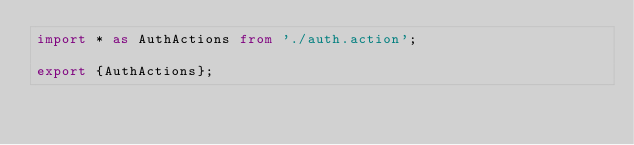Convert code to text. <code><loc_0><loc_0><loc_500><loc_500><_TypeScript_>import * as AuthActions from './auth.action';

export {AuthActions};</code> 